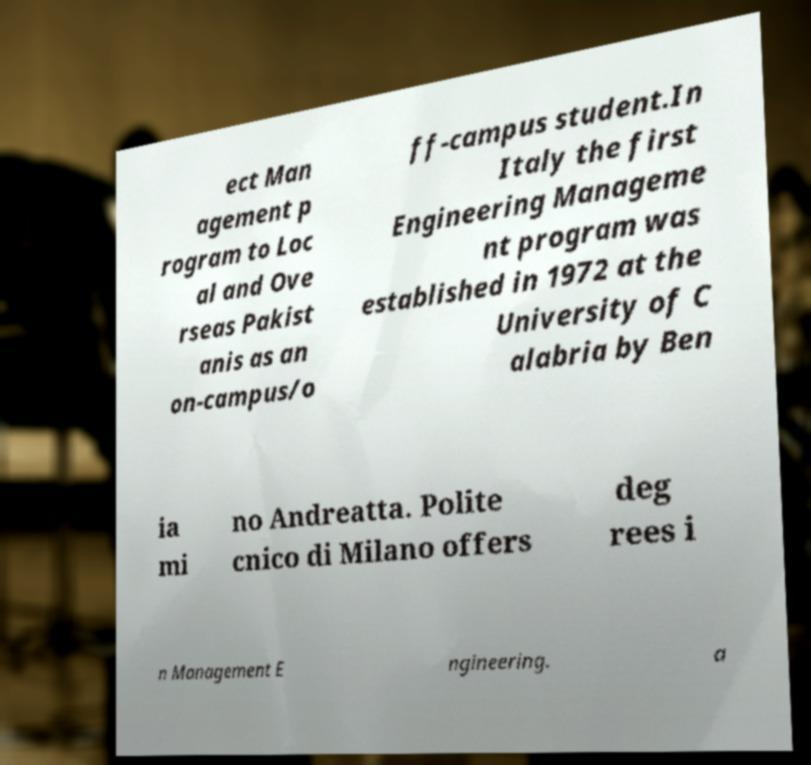Can you accurately transcribe the text from the provided image for me? ect Man agement p rogram to Loc al and Ove rseas Pakist anis as an on-campus/o ff-campus student.In Italy the first Engineering Manageme nt program was established in 1972 at the University of C alabria by Ben ia mi no Andreatta. Polite cnico di Milano offers deg rees i n Management E ngineering. a 